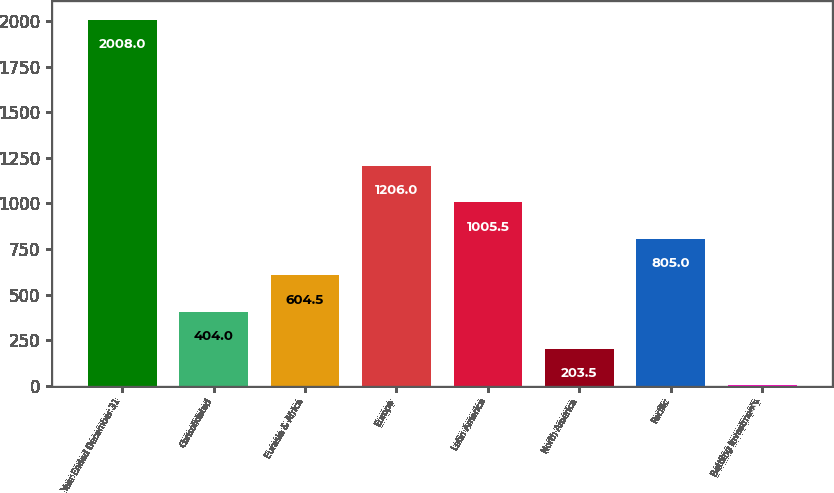Convert chart. <chart><loc_0><loc_0><loc_500><loc_500><bar_chart><fcel>Year Ended December 31<fcel>Consolidated<fcel>Eurasia & Africa<fcel>Europe<fcel>Latin America<fcel>North America<fcel>Pacific<fcel>Bottling Investments<nl><fcel>2008<fcel>404<fcel>604.5<fcel>1206<fcel>1005.5<fcel>203.5<fcel>805<fcel>3<nl></chart> 